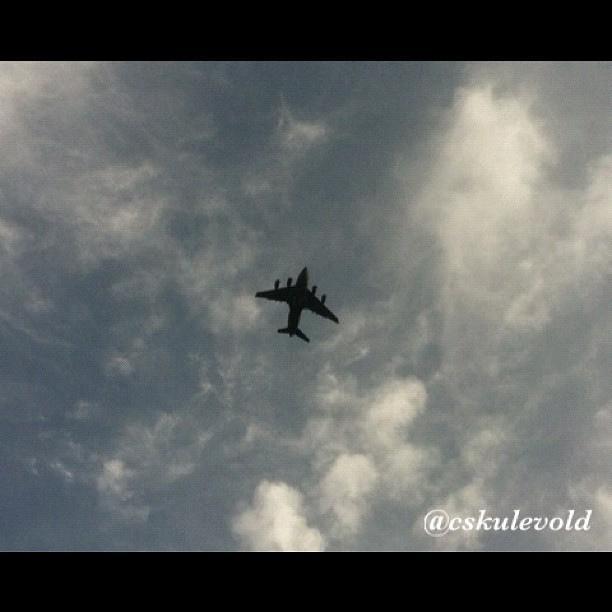How many engines does this plane have?
Give a very brief answer. 4. How many trees are in the background?
Give a very brief answer. 0. How many engines does the airplane have?
Give a very brief answer. 4. How many people are wearing glasses?
Give a very brief answer. 0. 